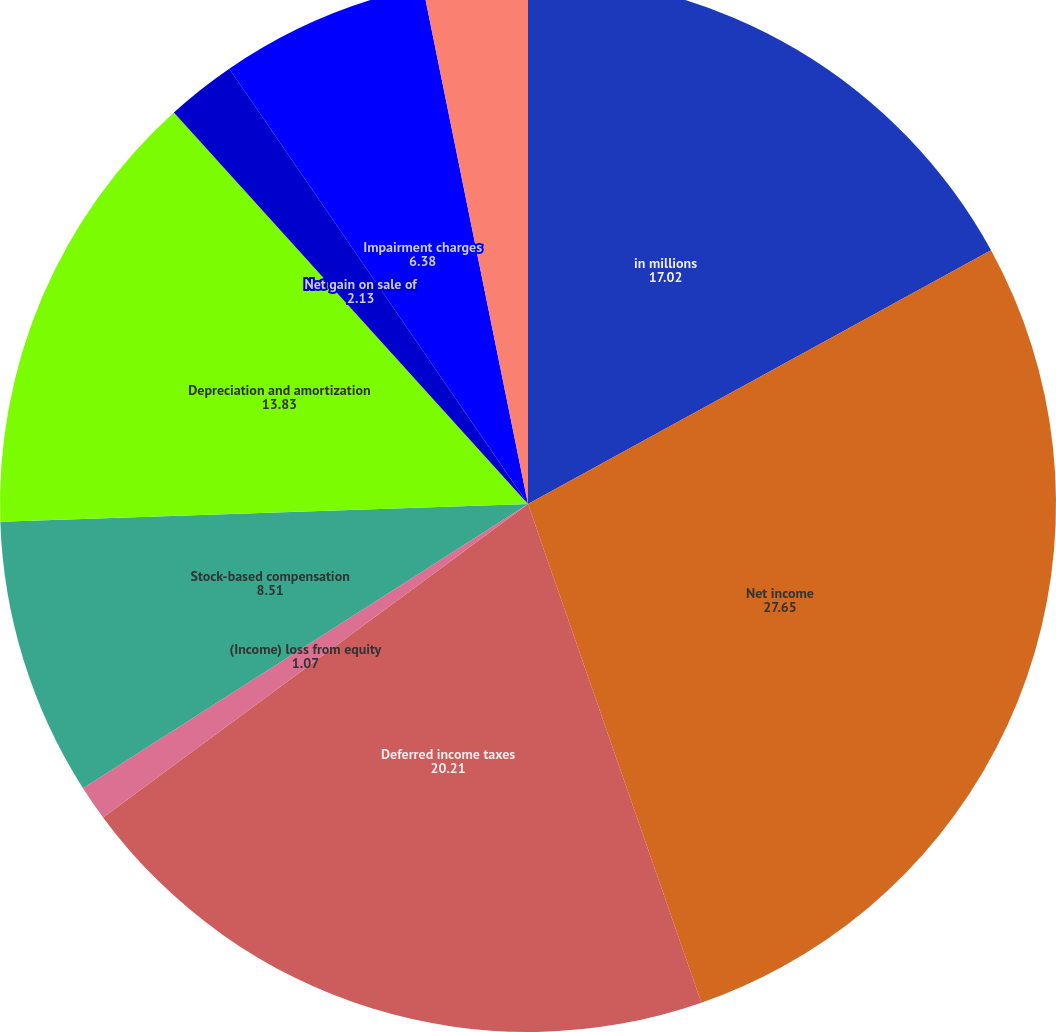Convert chart to OTSL. <chart><loc_0><loc_0><loc_500><loc_500><pie_chart><fcel>in millions<fcel>Net income<fcel>Deferred income taxes<fcel>(Income) loss from equity<fcel>Stock-based compensation<fcel>Depreciation and amortization<fcel>Net gain on sale of<fcel>Impairment charges<fcel>Provision for credit losses on<fcel>Other operating adjustments<nl><fcel>17.02%<fcel>27.65%<fcel>20.21%<fcel>1.07%<fcel>8.51%<fcel>13.83%<fcel>2.13%<fcel>6.38%<fcel>0.0%<fcel>3.19%<nl></chart> 